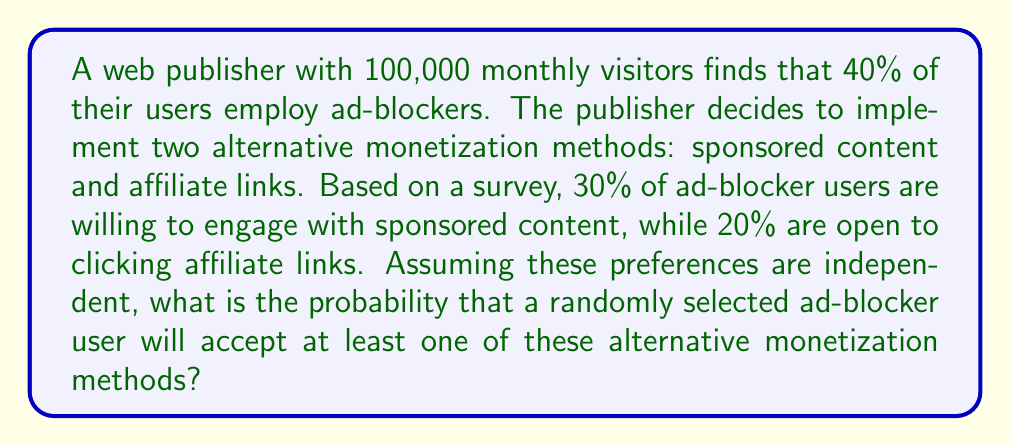Solve this math problem. Let's approach this step-by-step:

1) First, we need to calculate the probability that an ad-blocker user will not engage with either monetization method.

2) Let's define our events:
   S: User engages with sponsored content
   A: User clicks on affiliate links

3) We're given:
   P(S) = 0.30
   P(A) = 0.20

4) The probability of not engaging with sponsored content is:
   P(not S) = 1 - P(S) = 1 - 0.30 = 0.70

5) The probability of not clicking affiliate links is:
   P(not A) = 1 - P(A) = 1 - 0.20 = 0.80

6) Assuming independence, the probability of not engaging with either method is:
   P(not S and not A) = P(not S) × P(not A) = 0.70 × 0.80 = 0.56

7) Therefore, the probability of engaging with at least one method is:
   P(S or A) = 1 - P(not S and not A) = 1 - 0.56 = 0.44

8) We can verify this using the inclusion-exclusion principle:
   P(S or A) = P(S) + P(A) - P(S and A)
              = 0.30 + 0.20 - (0.30 × 0.20)
              = 0.50 - 0.06
              = 0.44

Thus, the probability that a randomly selected ad-blocker user will accept at least one of these alternative monetization methods is 0.44 or 44%.
Answer: 0.44 or 44% 